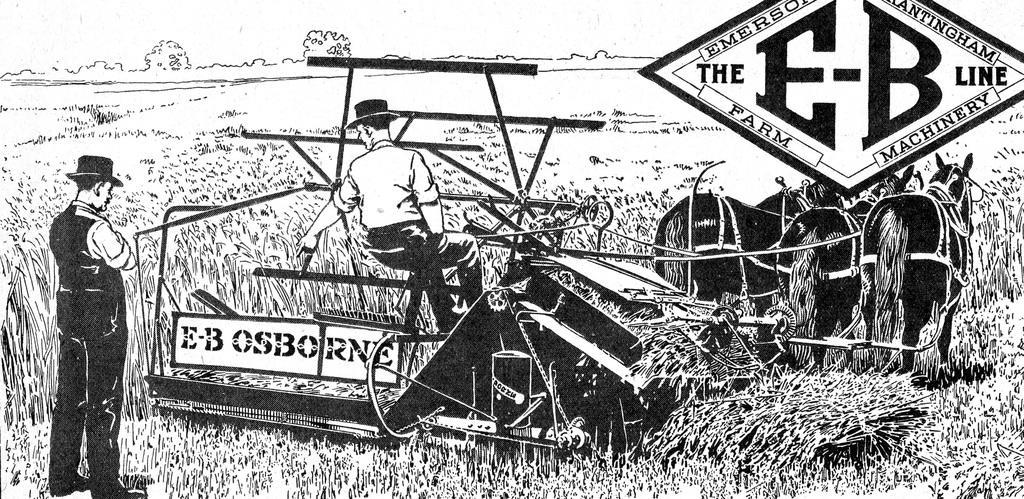Could you give a brief overview of what you see in this image? It is an edited image in which we can see there is a man who is standing on the ground. In front of him there is another person who is sitting on the harvesting machine and harvesting the crops. On the right side top there is a board. At the bottom there are horses. 